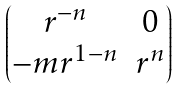Convert formula to latex. <formula><loc_0><loc_0><loc_500><loc_500>\begin{pmatrix} r ^ { - n } & 0 \\ - m r ^ { 1 - n } & r ^ { n } \end{pmatrix}</formula> 